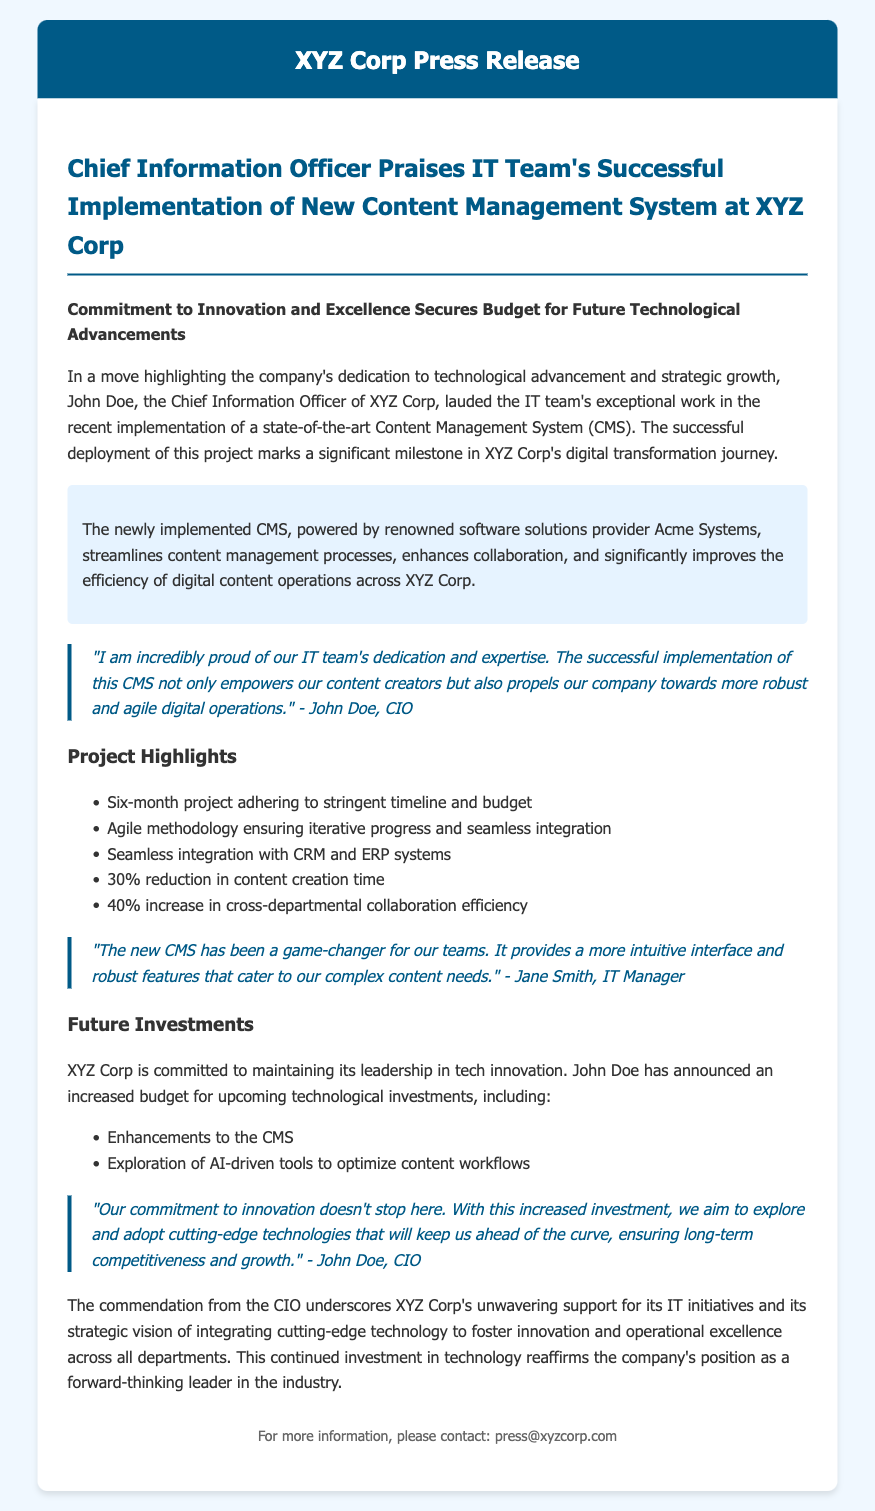What is the name of the software solutions provider for the CMS? The document states that the newly implemented CMS is powered by Acme Systems.
Answer: Acme Systems Who commended the IT team for their work on the CMS project? The document mentions John Doe, the Chief Information Officer, praising the IT team's efforts.
Answer: John Doe What percentage reduction in content creation time was achieved? According to the project highlights, the implementation resulted in a 30% reduction in content creation time.
Answer: 30% What is the main purpose of the newly implemented CMS? The highlight section indicates that the CMS streamlines content management processes and enhances collaboration.
Answer: Streamlines content management processes How long did the CMS project take? The document specifies that the project adhered to a six-month timeline.
Answer: Six months What future technological investment is mentioned in the document? The CIO mentioned exploring AI-driven tools to optimize content workflows as part of future investments.
Answer: AI-driven tools What Agile methodology aspect was emphasized during the CMS implementation? The document refers to an iterative progress and seamless integration as key features of the Agile methodology used.
Answer: Iterative progress What key benefit does the CIO emphasize regarding the CMS? John Doe says the successful implementation empowers content creators and propels the company towards agile digital operations.
Answer: Empowers content creators What is the overall message conveyed by the CIO's commendation? The commendation highlights XYZ Corp's unwavering support for IT initiatives and commitment to integrating cutting-edge technology.
Answer: Support for IT initiatives 